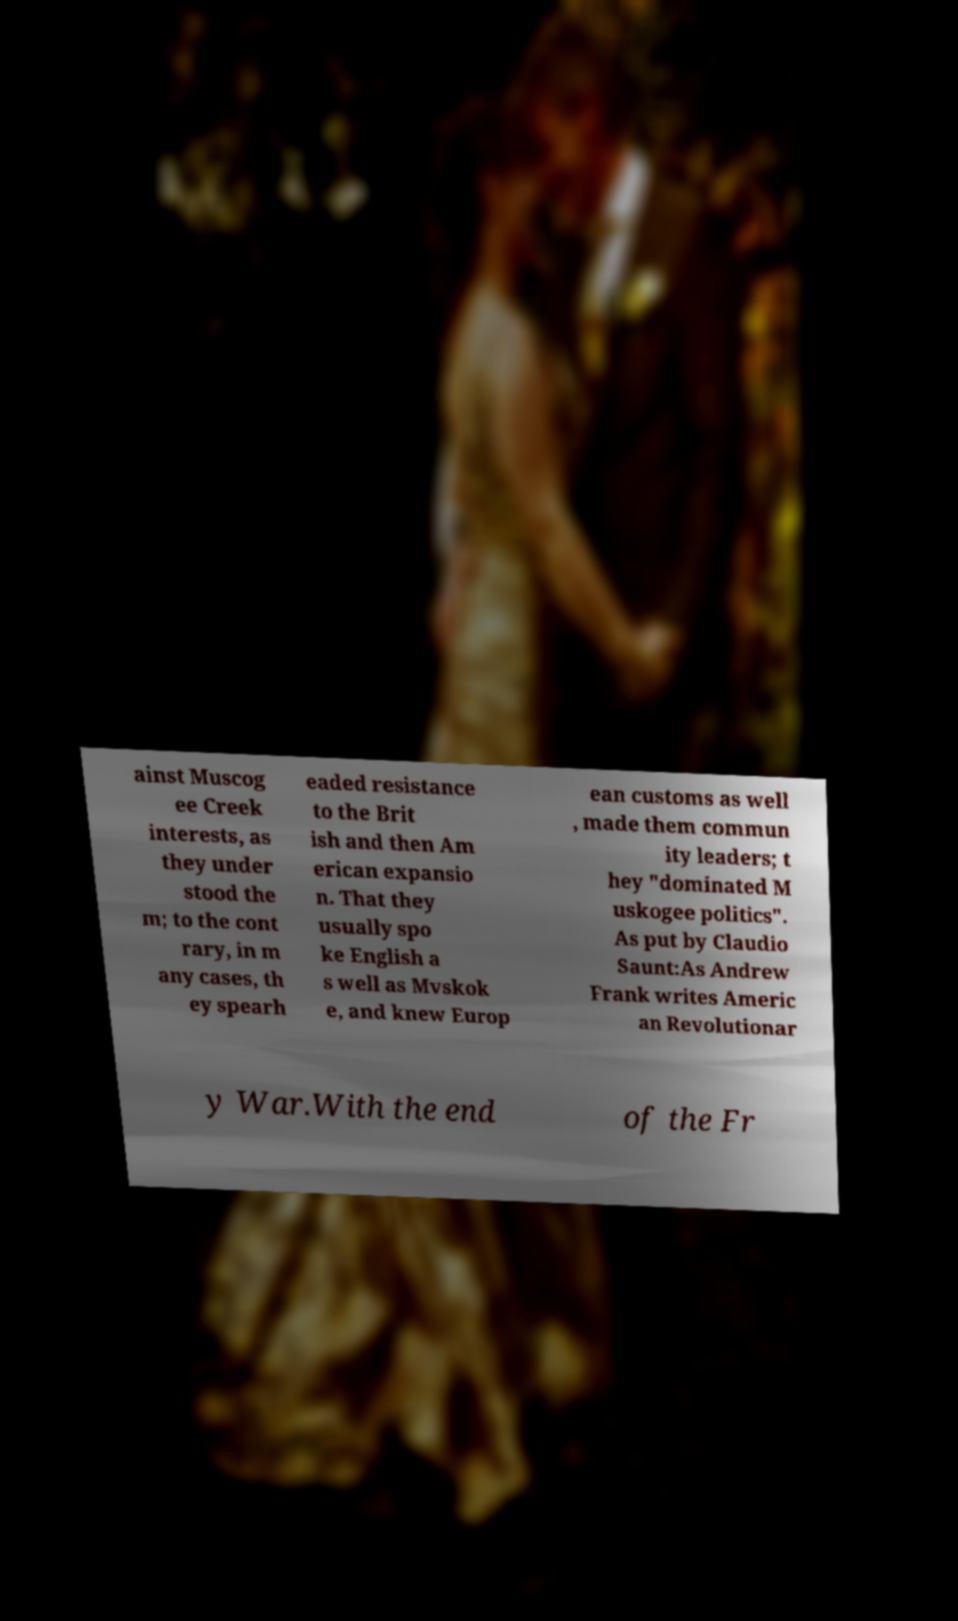Please identify and transcribe the text found in this image. ainst Muscog ee Creek interests, as they under stood the m; to the cont rary, in m any cases, th ey spearh eaded resistance to the Brit ish and then Am erican expansio n. That they usually spo ke English a s well as Mvskok e, and knew Europ ean customs as well , made them commun ity leaders; t hey "dominated M uskogee politics". As put by Claudio Saunt:As Andrew Frank writes Americ an Revolutionar y War.With the end of the Fr 